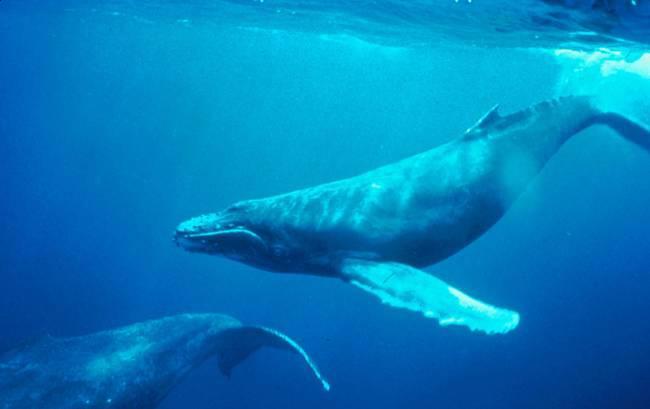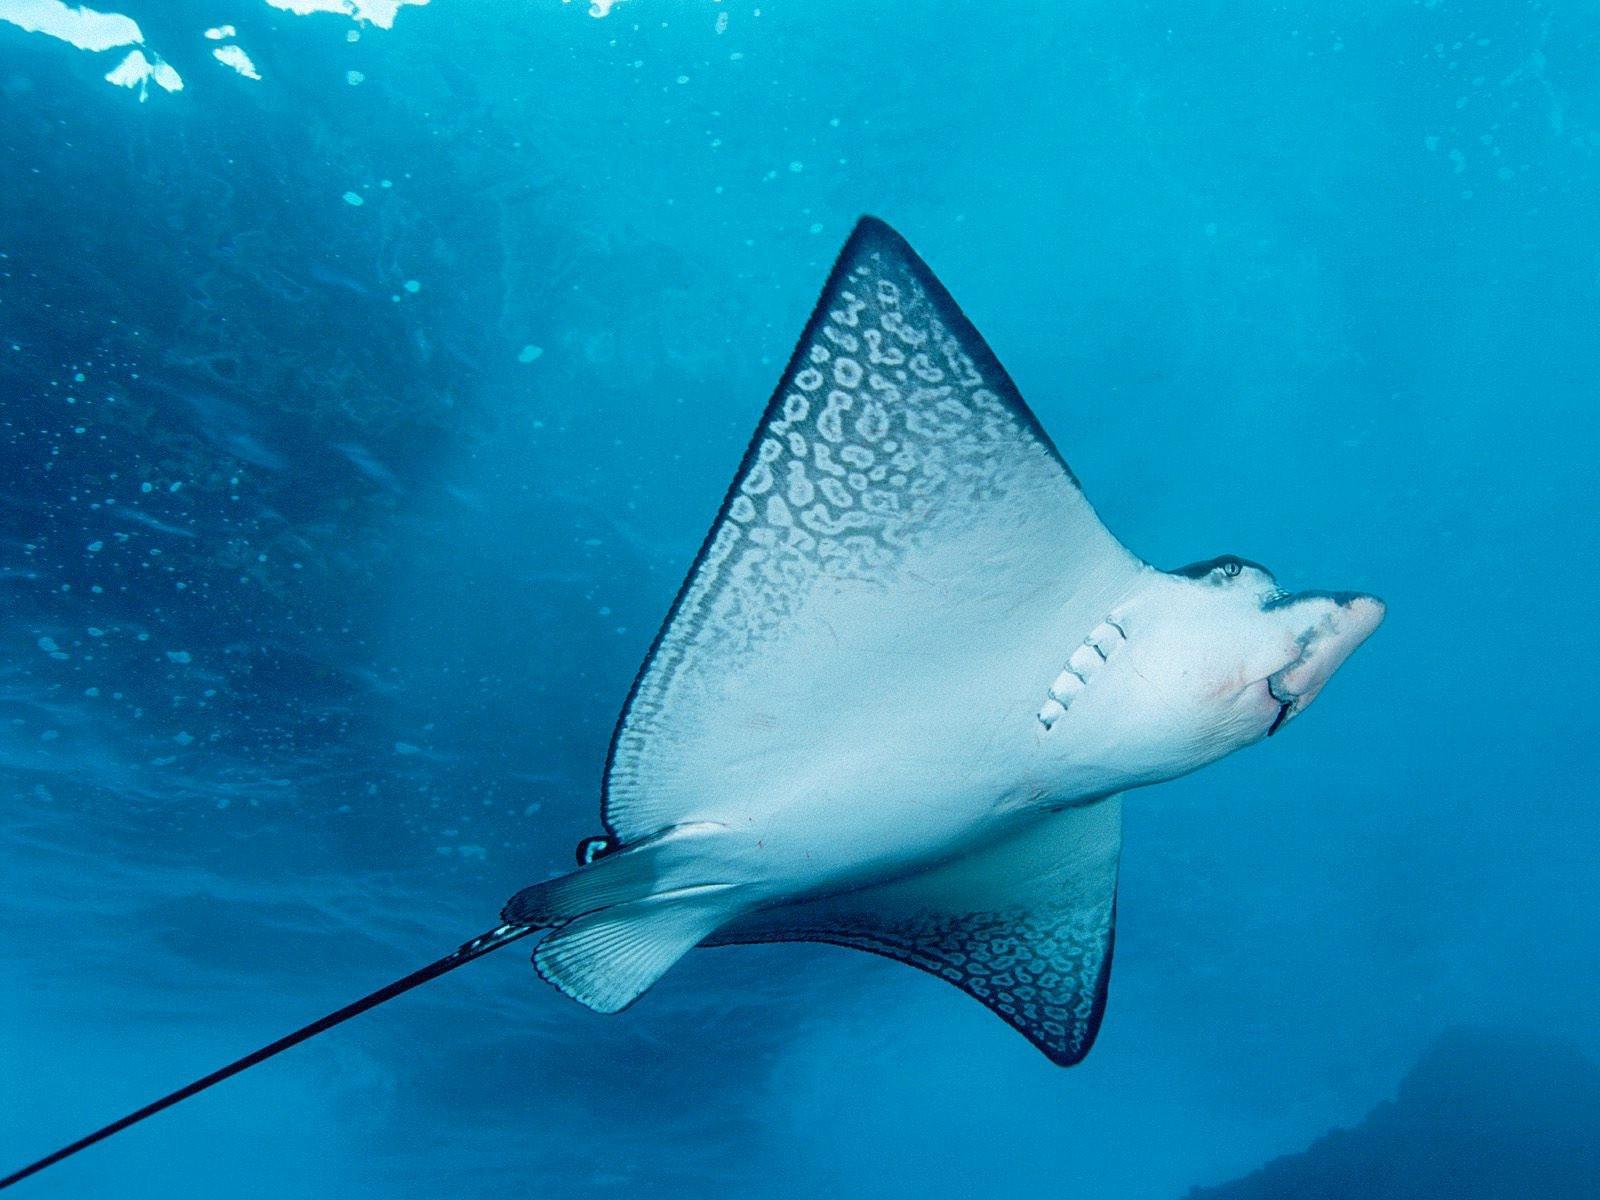The first image is the image on the left, the second image is the image on the right. Considering the images on both sides, is "There are exactly two animals in the image on the left." valid? Answer yes or no. Yes. The first image is the image on the left, the second image is the image on the right. Evaluate the accuracy of this statement regarding the images: "There are no more than two stingrays.". Is it true? Answer yes or no. Yes. 